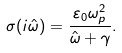Convert formula to latex. <formula><loc_0><loc_0><loc_500><loc_500>\sigma ( i \hat { \omega } ) = \frac { \varepsilon _ { 0 } \omega _ { p } ^ { 2 } } { \hat { \omega } + \gamma } .</formula> 